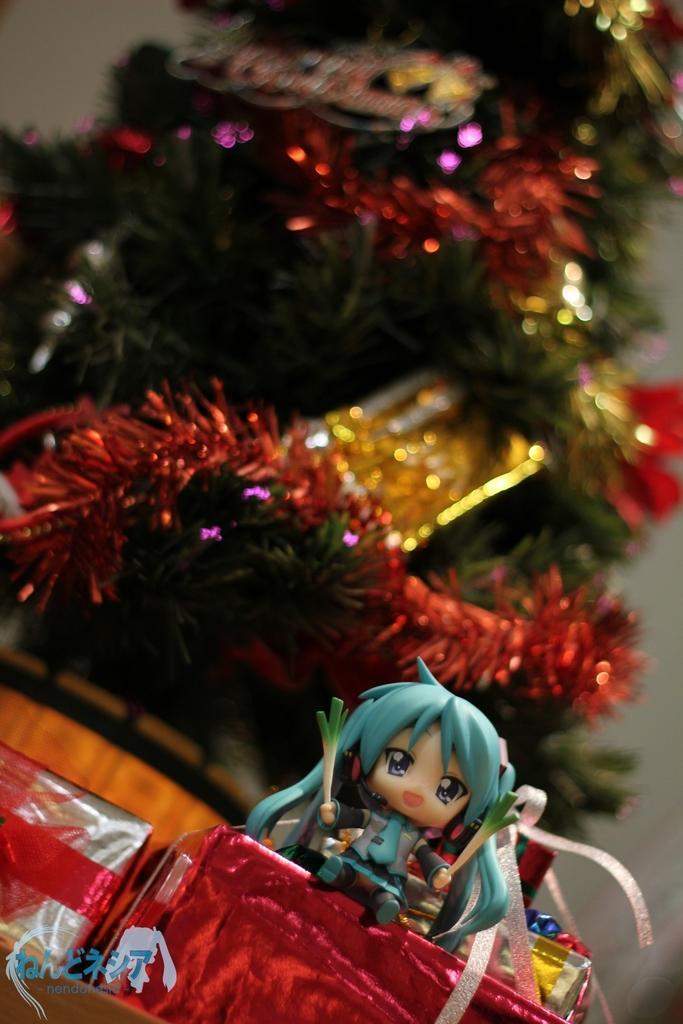Describe this image in one or two sentences. On the right side, there is a toy placed on a red color gift box. Beside this box, there is a silver color gift box. On the bottom left, there is a watermark. In the background, there is a Christmas tree and there is a white wall. 